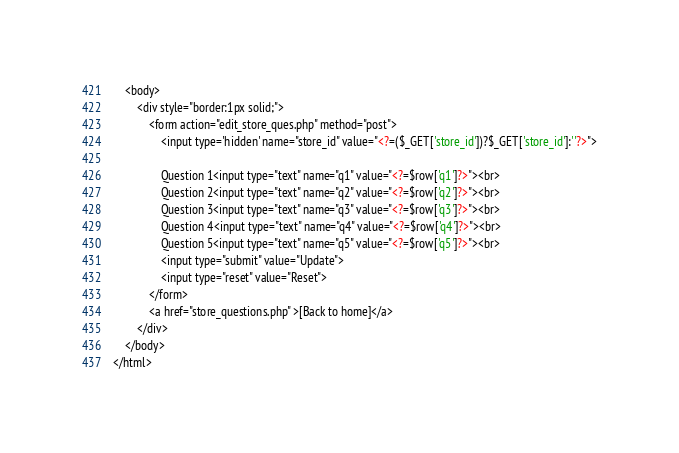Convert code to text. <code><loc_0><loc_0><loc_500><loc_500><_PHP_>	<body>
		<div style="border:1px solid;"> 
			<form action="edit_store_ques.php" method="post">
				<input type='hidden' name="store_id" value="<?=($_GET['store_id'])?$_GET['store_id']:''?>">
				
	    	    Question 1<input type="text" name="q1" value="<?=$row['q1']?>"><br>
        	    Question 2<input type="text" name="q2" value="<?=$row['q2']?>"><br>
        	    Question 3<input type="text" name="q3" value="<?=$row['q3']?>"><br>
        	    Question 4<input type="text" name="q4" value="<?=$row['q4']?>"><br>
        	    Question 5<input type="text" name="q5" value="<?=$row['q5']?>"><br>
				<input type="submit" value="Update">
				<input type="reset" value="Reset">
			</form>    
			<a href="store_questions.php" >[Back to home]</a>
		</div>
	</body>
</html>
</code> 